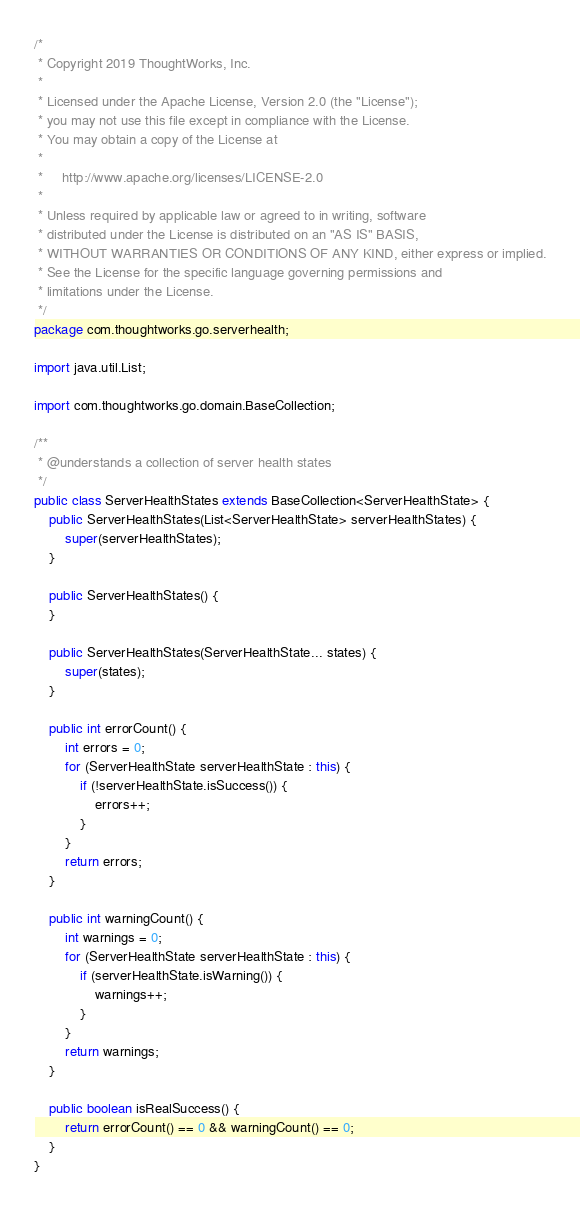Convert code to text. <code><loc_0><loc_0><loc_500><loc_500><_Java_>/*
 * Copyright 2019 ThoughtWorks, Inc.
 *
 * Licensed under the Apache License, Version 2.0 (the "License");
 * you may not use this file except in compliance with the License.
 * You may obtain a copy of the License at
 *
 *     http://www.apache.org/licenses/LICENSE-2.0
 *
 * Unless required by applicable law or agreed to in writing, software
 * distributed under the License is distributed on an "AS IS" BASIS,
 * WITHOUT WARRANTIES OR CONDITIONS OF ANY KIND, either express or implied.
 * See the License for the specific language governing permissions and
 * limitations under the License.
 */
package com.thoughtworks.go.serverhealth;

import java.util.List;

import com.thoughtworks.go.domain.BaseCollection;

/**
 * @understands a collection of server health states
 */
public class ServerHealthStates extends BaseCollection<ServerHealthState> {
    public ServerHealthStates(List<ServerHealthState> serverHealthStates) {
        super(serverHealthStates);
    }

    public ServerHealthStates() {
    }

    public ServerHealthStates(ServerHealthState... states) {
        super(states);
    }

    public int errorCount() {
        int errors = 0;
        for (ServerHealthState serverHealthState : this) {
            if (!serverHealthState.isSuccess()) {
                errors++;
            }
        }
        return errors;
    }

    public int warningCount() {
        int warnings = 0;
        for (ServerHealthState serverHealthState : this) {
            if (serverHealthState.isWarning()) {
                warnings++;
            }
        }
        return warnings;
    }

    public boolean isRealSuccess() {
        return errorCount() == 0 && warningCount() == 0;
    }
}
</code> 